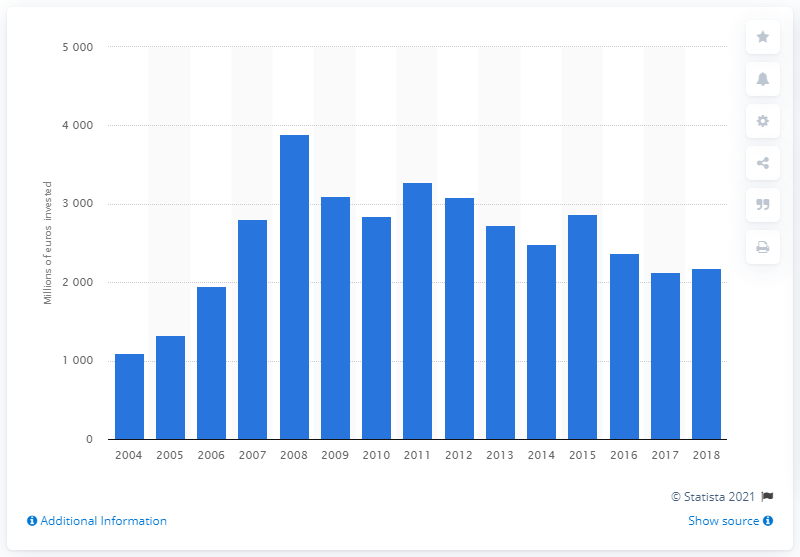Draw attention to some important aspects in this diagram. In 2018, a significant amount of money was invested in the road transport infrastructure in Romania, totaling 2,181.56. 